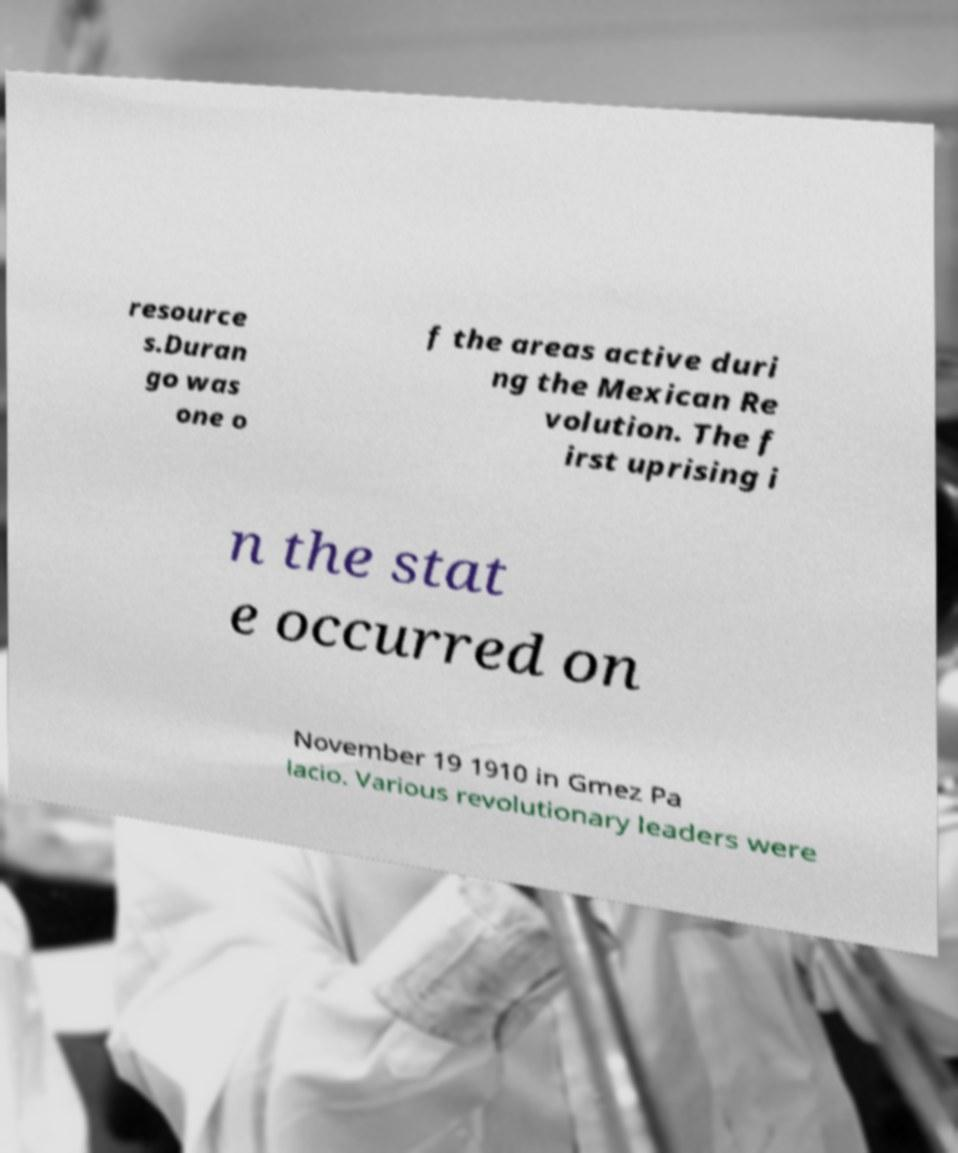For documentation purposes, I need the text within this image transcribed. Could you provide that? resource s.Duran go was one o f the areas active duri ng the Mexican Re volution. The f irst uprising i n the stat e occurred on November 19 1910 in Gmez Pa lacio. Various revolutionary leaders were 